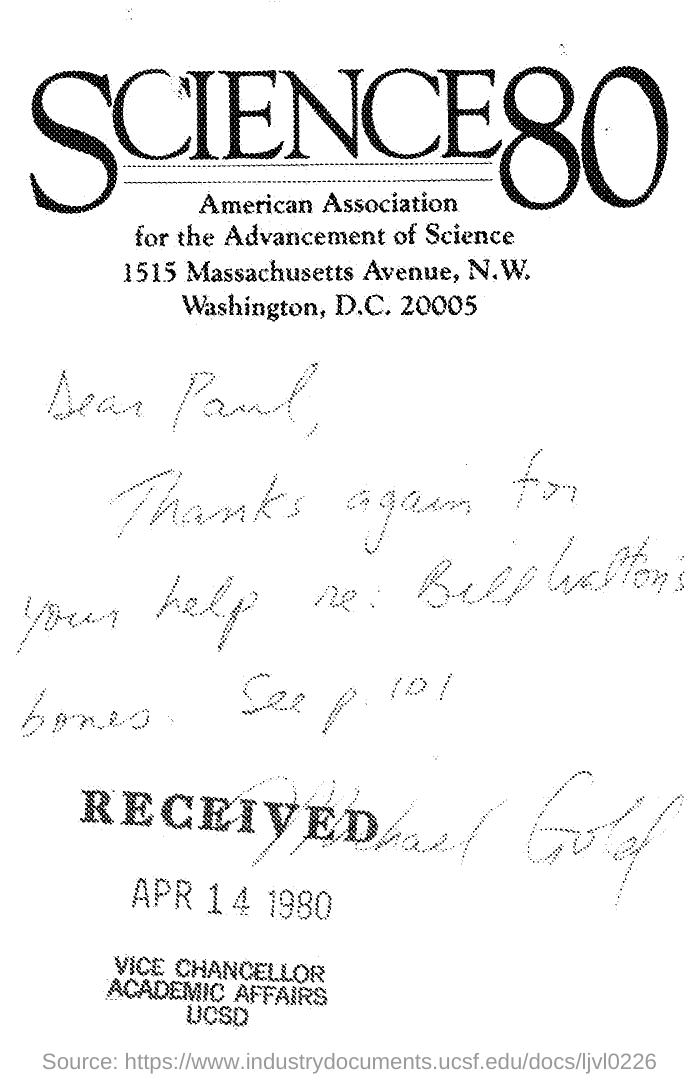To whom this was sent?
Offer a terse response. Paul. Who wrote it?
Ensure brevity in your answer.  Michael Gold. 